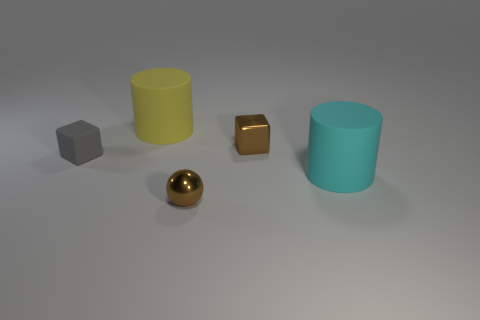Add 1 tiny brown metal balls. How many objects exist? 6 Subtract all balls. How many objects are left? 4 Subtract all tiny red matte balls. Subtract all big cyan things. How many objects are left? 4 Add 3 rubber objects. How many rubber objects are left? 6 Add 1 big shiny cylinders. How many big shiny cylinders exist? 1 Subtract 0 gray cylinders. How many objects are left? 5 